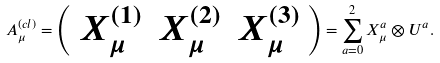<formula> <loc_0><loc_0><loc_500><loc_500>A _ { \mu } ^ { ( c l ) } = \left ( \begin{array} { c c c } { { X _ { \mu } ^ { ( 1 ) } } } & { { X _ { \mu } ^ { ( 2 ) } } } & { { X _ { \mu } ^ { ( 3 ) } } } \end{array} \right ) = \sum _ { a = 0 } ^ { 2 } X _ { \mu } ^ { a } \otimes U ^ { a } .</formula> 